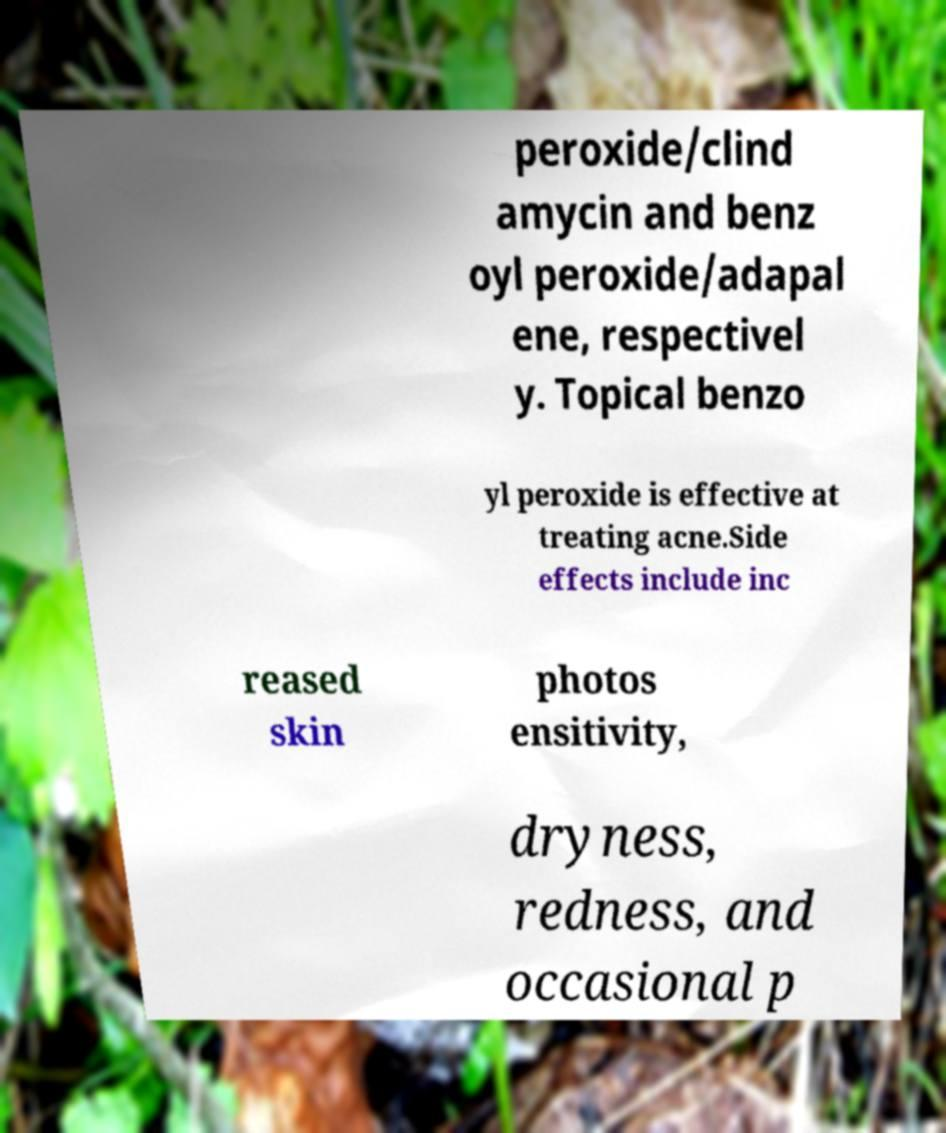There's text embedded in this image that I need extracted. Can you transcribe it verbatim? peroxide/clind amycin and benz oyl peroxide/adapal ene, respectivel y. Topical benzo yl peroxide is effective at treating acne.Side effects include inc reased skin photos ensitivity, dryness, redness, and occasional p 